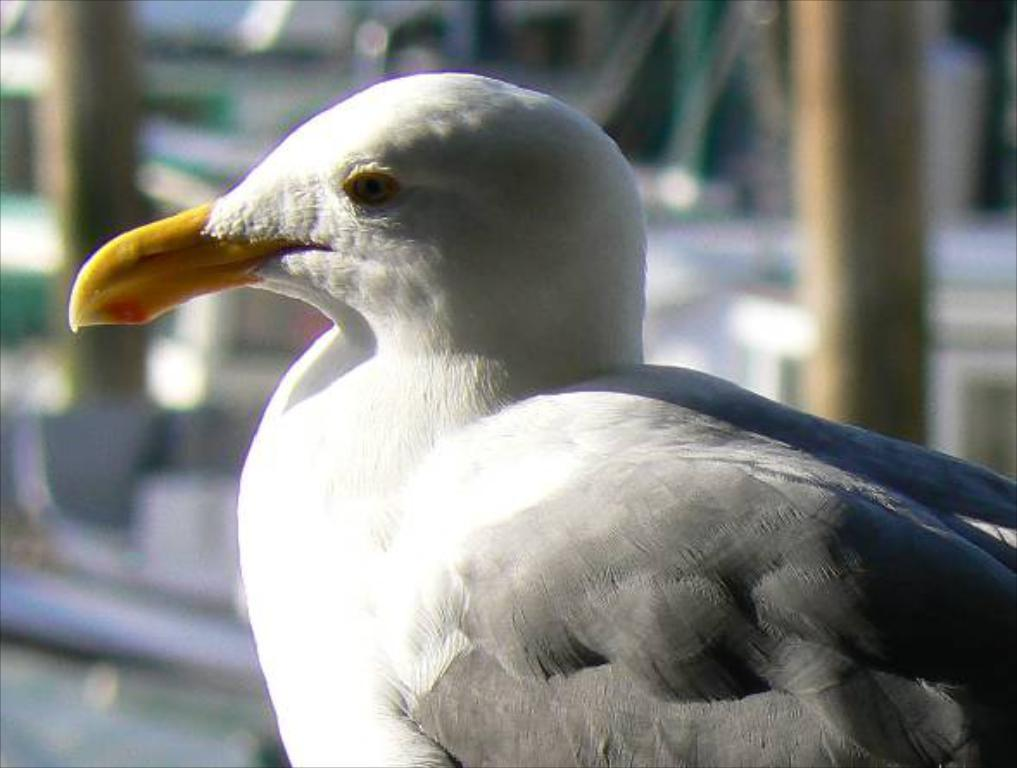What type of bird is in the image? There is a gull bird in the image. What can be seen in the background of the bird? The background of the bird is blue. What type of acoustics can be heard coming from the bird in the image? There is no indication in the image that any sounds can be heard coming from the bird. What type of roll can be seen in the image? There is no roll present in the image. Is there a stranger interacting with the bird in the image? There is no stranger present in the image. 